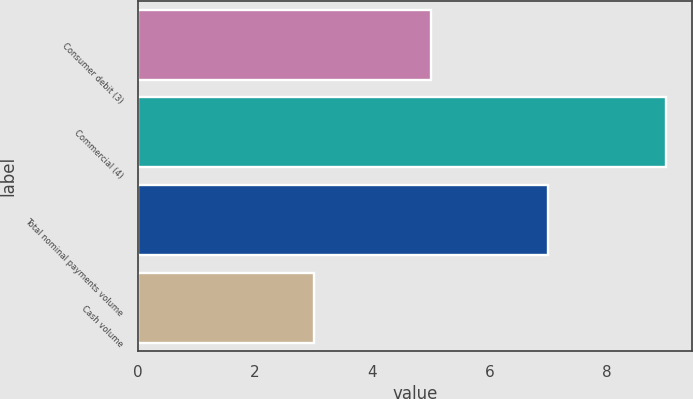Convert chart to OTSL. <chart><loc_0><loc_0><loc_500><loc_500><bar_chart><fcel>Consumer debit (3)<fcel>Commercial (4)<fcel>Total nominal payments volume<fcel>Cash volume<nl><fcel>5<fcel>9<fcel>7<fcel>3<nl></chart> 